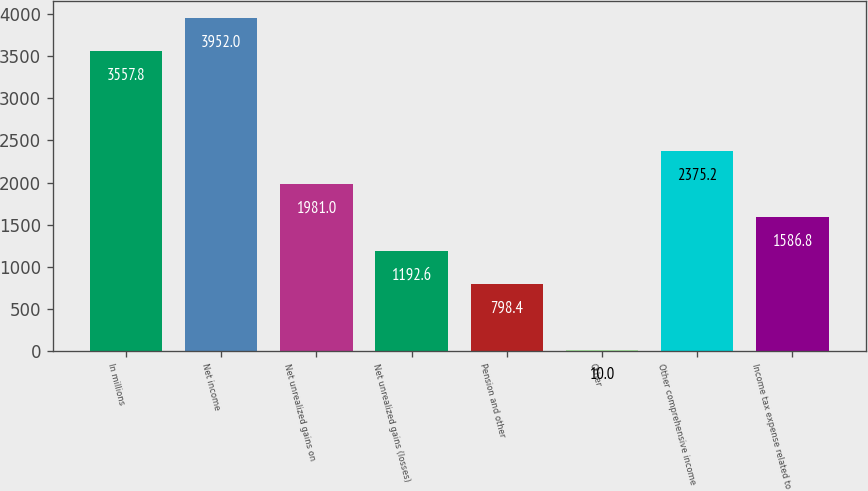Convert chart. <chart><loc_0><loc_0><loc_500><loc_500><bar_chart><fcel>In millions<fcel>Net income<fcel>Net unrealized gains on<fcel>Net unrealized gains (losses)<fcel>Pension and other<fcel>Other<fcel>Other comprehensive income<fcel>Income tax expense related to<nl><fcel>3557.8<fcel>3952<fcel>1981<fcel>1192.6<fcel>798.4<fcel>10<fcel>2375.2<fcel>1586.8<nl></chart> 